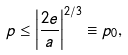Convert formula to latex. <formula><loc_0><loc_0><loc_500><loc_500>p \leq \left | \frac { 2 e } { a } \right | ^ { 2 / 3 } \equiv p _ { 0 } ,</formula> 